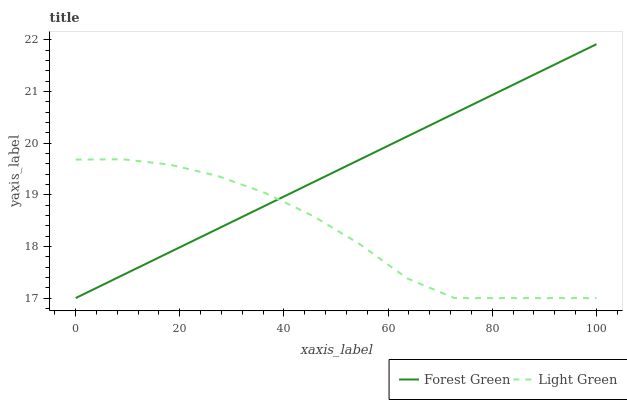Does Light Green have the minimum area under the curve?
Answer yes or no. Yes. Does Forest Green have the maximum area under the curve?
Answer yes or no. Yes. Does Light Green have the maximum area under the curve?
Answer yes or no. No. Is Forest Green the smoothest?
Answer yes or no. Yes. Is Light Green the roughest?
Answer yes or no. Yes. Is Light Green the smoothest?
Answer yes or no. No. Does Forest Green have the lowest value?
Answer yes or no. Yes. Does Forest Green have the highest value?
Answer yes or no. Yes. Does Light Green have the highest value?
Answer yes or no. No. Does Forest Green intersect Light Green?
Answer yes or no. Yes. Is Forest Green less than Light Green?
Answer yes or no. No. Is Forest Green greater than Light Green?
Answer yes or no. No. 